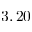<formula> <loc_0><loc_0><loc_500><loc_500>3 , 2 0</formula> 